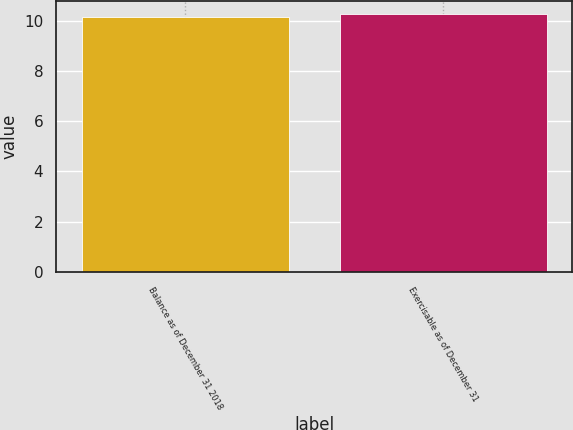<chart> <loc_0><loc_0><loc_500><loc_500><bar_chart><fcel>Balance as of December 31 2018<fcel>Exercisable as of December 31<nl><fcel>10.15<fcel>10.25<nl></chart> 